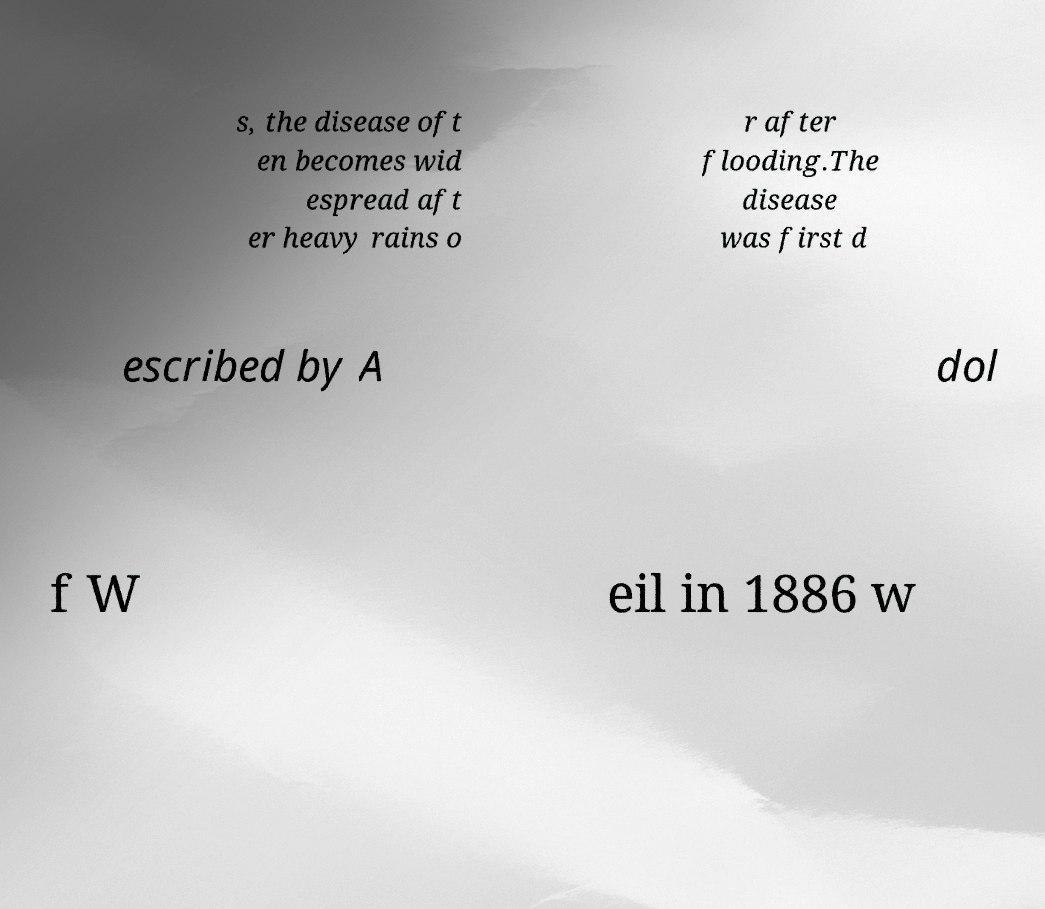Please read and relay the text visible in this image. What does it say? s, the disease oft en becomes wid espread aft er heavy rains o r after flooding.The disease was first d escribed by A dol f W eil in 1886 w 